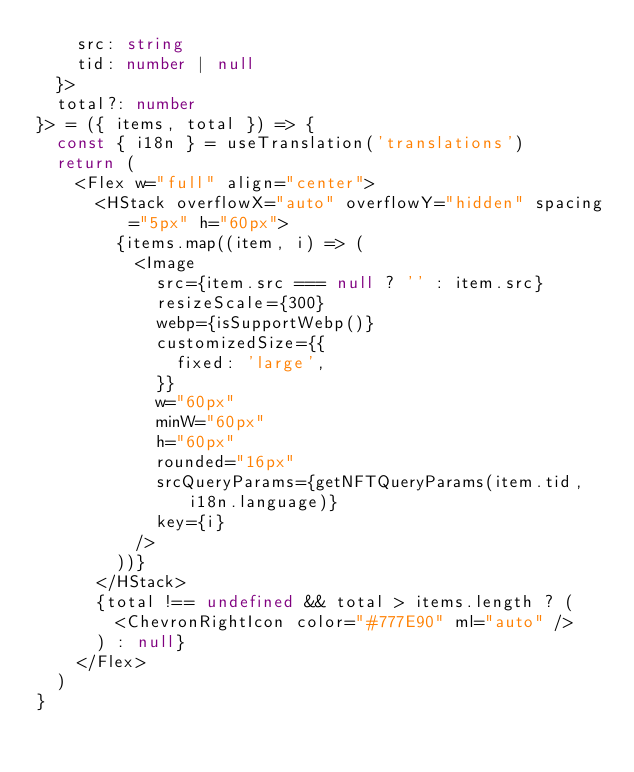<code> <loc_0><loc_0><loc_500><loc_500><_TypeScript_>    src: string
    tid: number | null
  }>
  total?: number
}> = ({ items, total }) => {
  const { i18n } = useTranslation('translations')
  return (
    <Flex w="full" align="center">
      <HStack overflowX="auto" overflowY="hidden" spacing="5px" h="60px">
        {items.map((item, i) => (
          <Image
            src={item.src === null ? '' : item.src}
            resizeScale={300}
            webp={isSupportWebp()}
            customizedSize={{
              fixed: 'large',
            }}
            w="60px"
            minW="60px"
            h="60px"
            rounded="16px"
            srcQueryParams={getNFTQueryParams(item.tid, i18n.language)}
            key={i}
          />
        ))}
      </HStack>
      {total !== undefined && total > items.length ? (
        <ChevronRightIcon color="#777E90" ml="auto" />
      ) : null}
    </Flex>
  )
}
</code> 